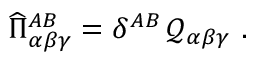Convert formula to latex. <formula><loc_0><loc_0><loc_500><loc_500>\widehat { \Pi } _ { \alpha \beta \gamma } ^ { A B } = \delta ^ { A B } \, \mathcal { Q } _ { \alpha \beta \gamma } .</formula> 